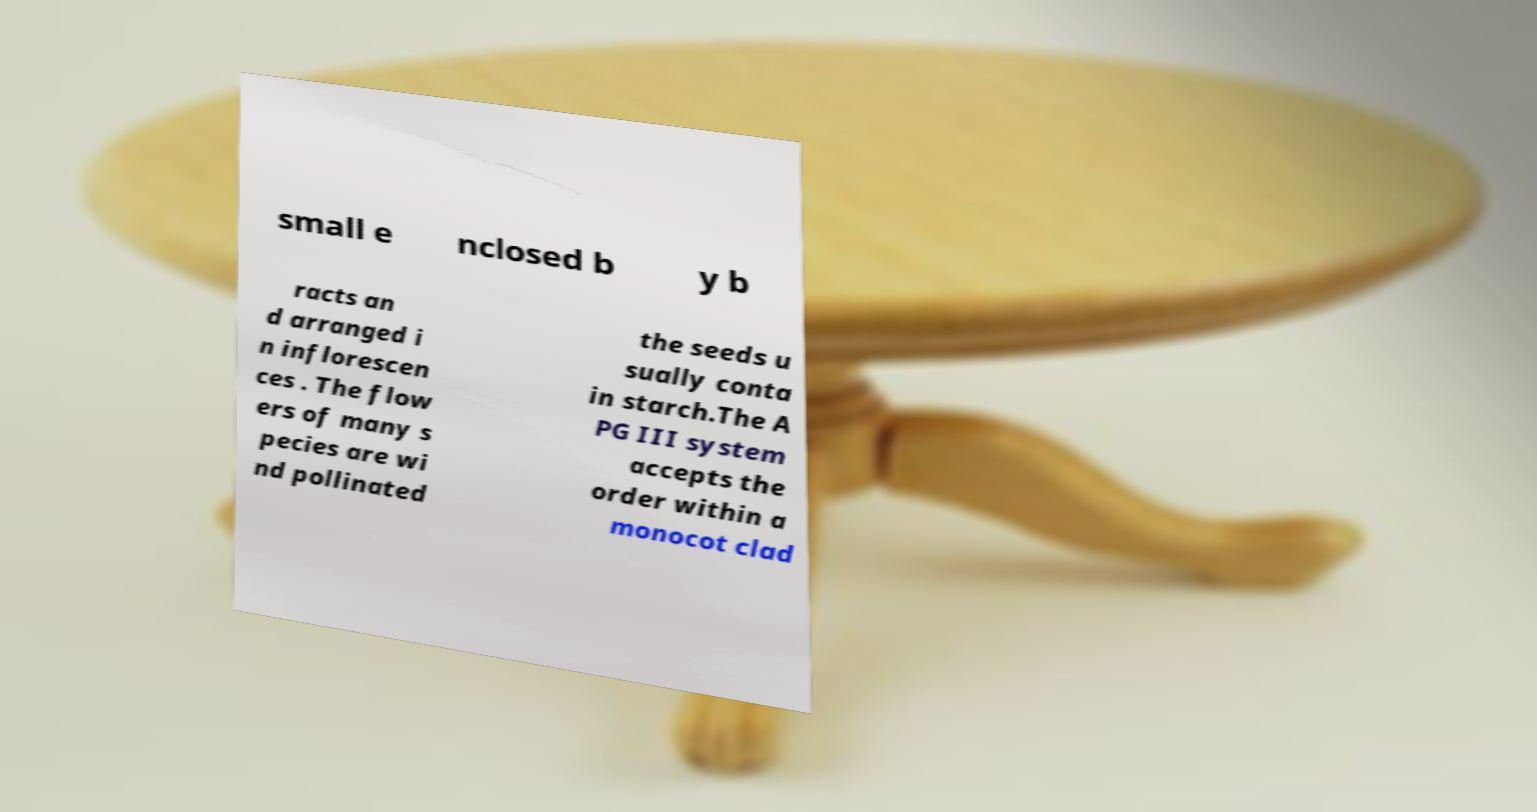Can you accurately transcribe the text from the provided image for me? small e nclosed b y b racts an d arranged i n inflorescen ces . The flow ers of many s pecies are wi nd pollinated the seeds u sually conta in starch.The A PG III system accepts the order within a monocot clad 